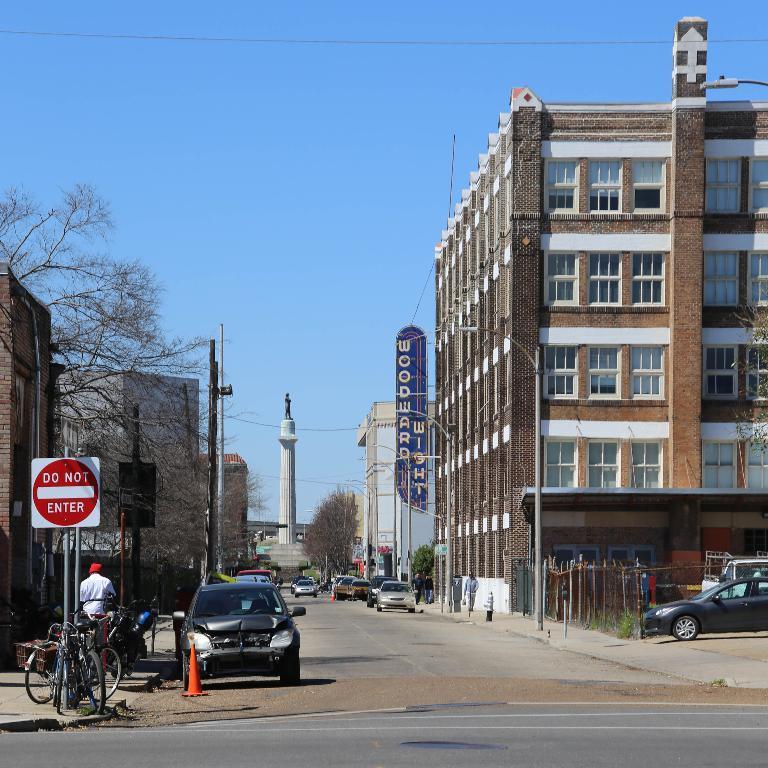How would you summarize this image in a sentence or two? In this image there are buildings and trees. We can see poles. In the center there is a tower. At the bottom there are vehicles on the road. There are people. In the background there is sky. 